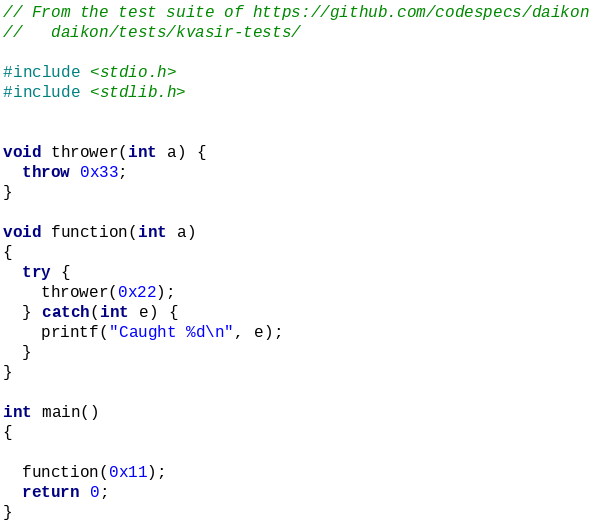Convert code to text. <code><loc_0><loc_0><loc_500><loc_500><_C++_>// From the test suite of https://github.com/codespecs/daikon
//   daikon/tests/kvasir-tests/

#include <stdio.h>
#include <stdlib.h>


void thrower(int a) {
  throw 0x33;
}

void function(int a)
{
  try {
    thrower(0x22);
  } catch(int e) {
    printf("Caught %d\n", e);
  }
}

int main()
{

  function(0x11);
  return 0;
}
</code> 